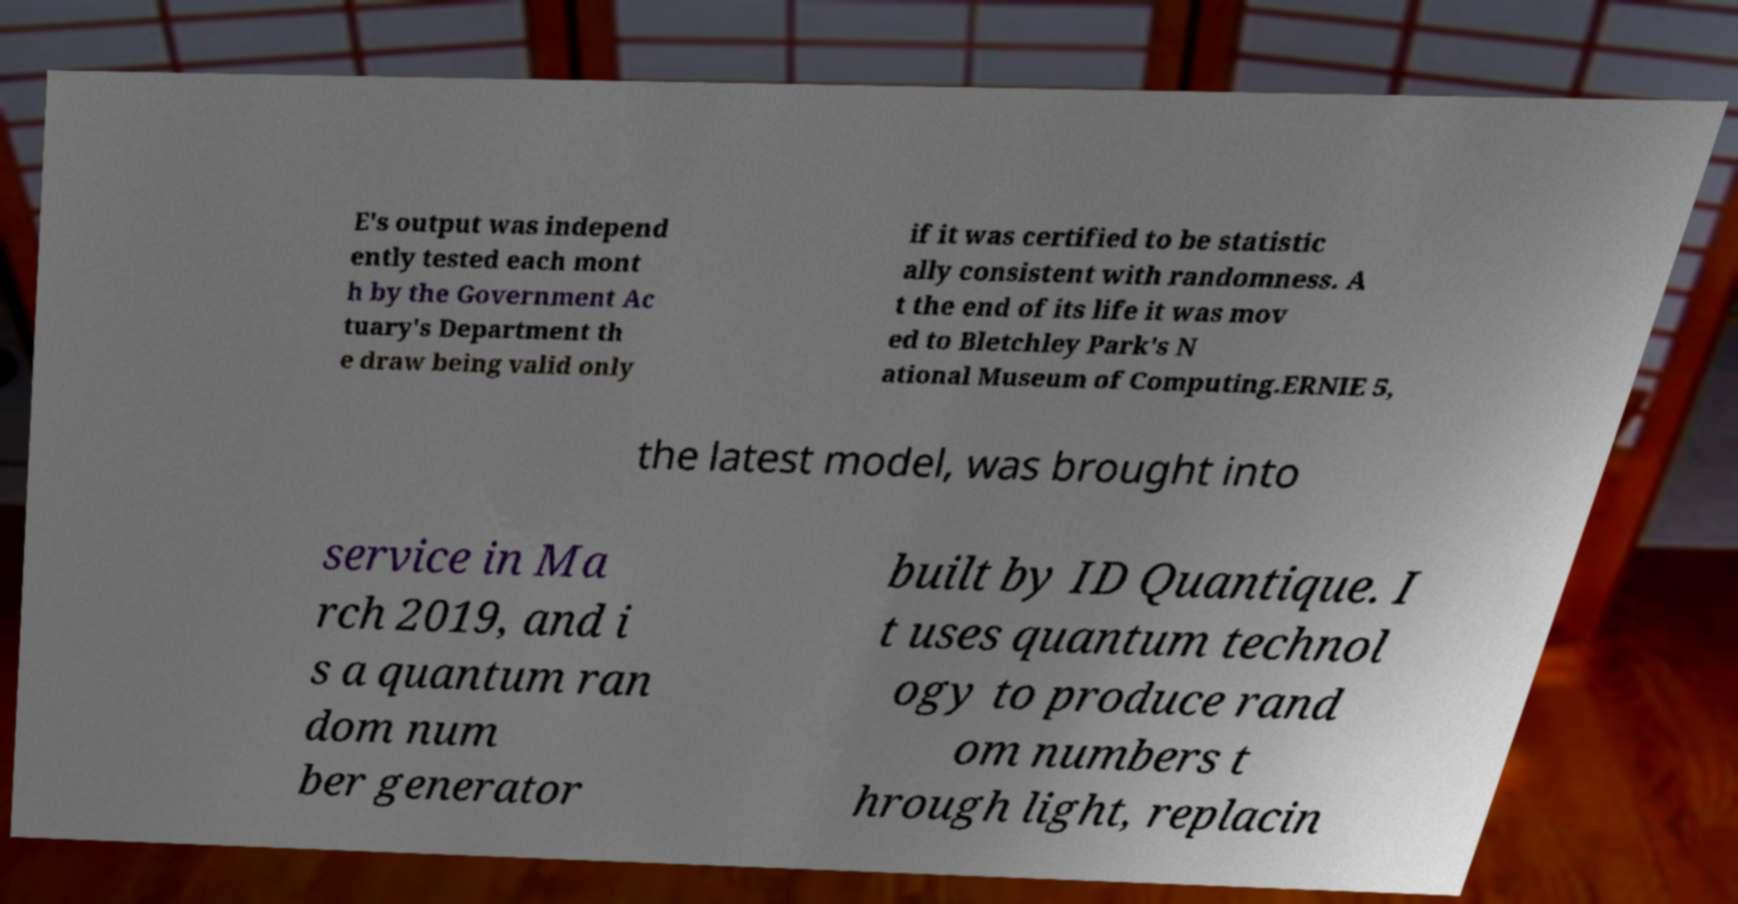Please identify and transcribe the text found in this image. E's output was independ ently tested each mont h by the Government Ac tuary's Department th e draw being valid only if it was certified to be statistic ally consistent with randomness. A t the end of its life it was mov ed to Bletchley Park's N ational Museum of Computing.ERNIE 5, the latest model, was brought into service in Ma rch 2019, and i s a quantum ran dom num ber generator built by ID Quantique. I t uses quantum technol ogy to produce rand om numbers t hrough light, replacin 